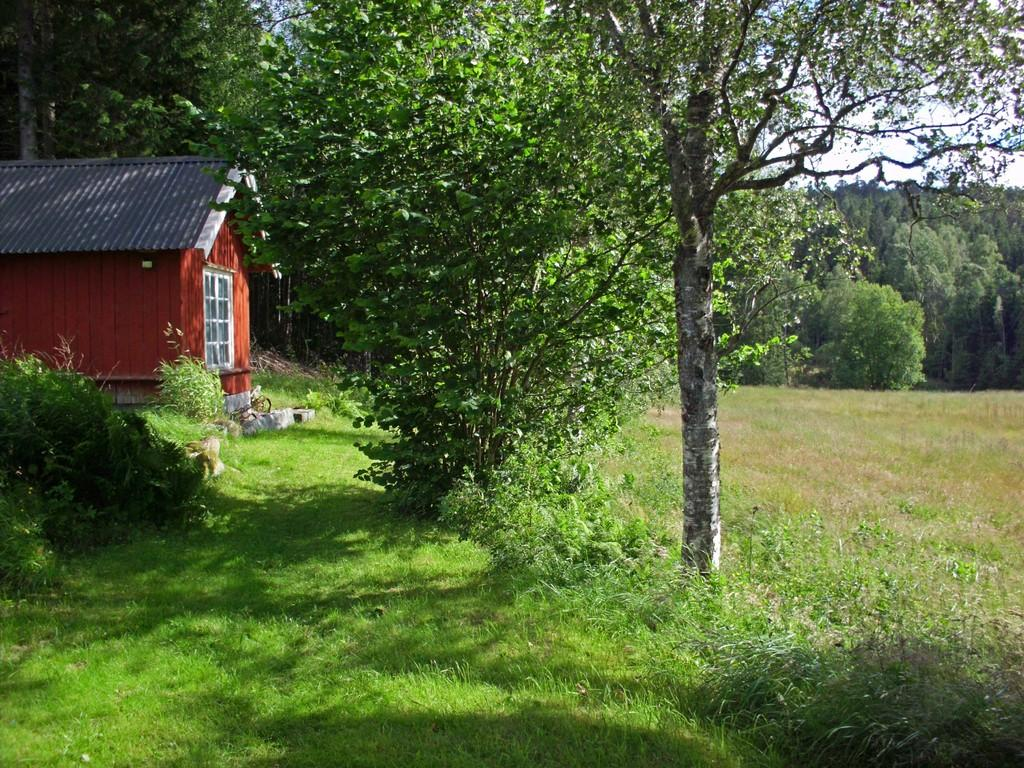What type of ground cover is present in the image? There is grass on the ground in the image. What other types of vegetation can be seen in the image? There are plants in the image. What structure is visible on the left side of the image? There is a house visible on the left side of the image. What can be seen in the background of the image? There are trees in the background of the image. What flavor of ice cream is being served in the morning in the image? There is no ice cream or morning reference in the image; it features grass, plants, a house, and trees. 